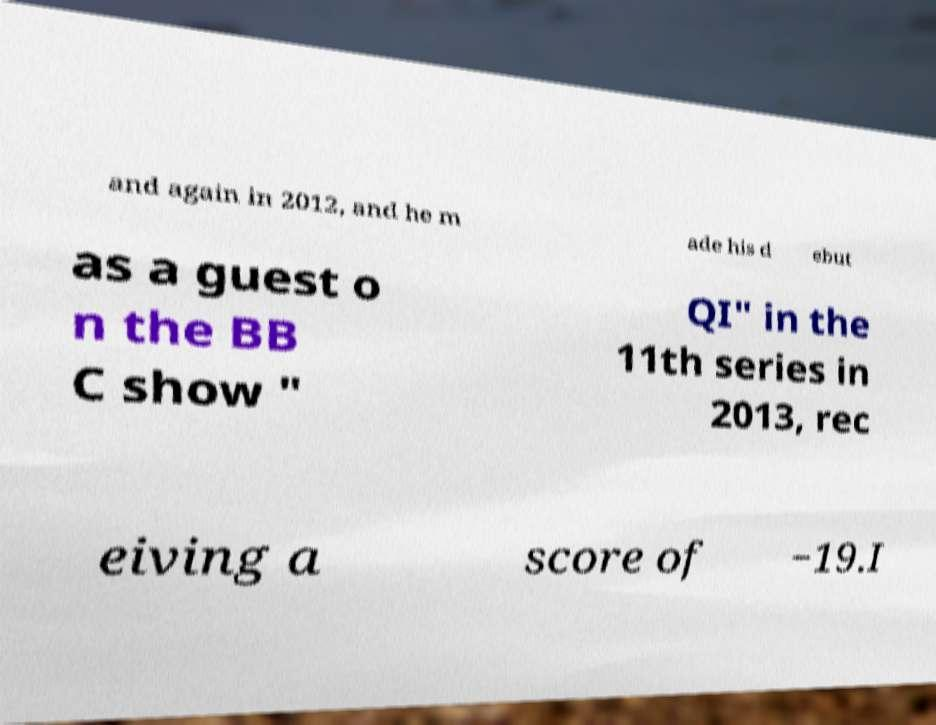Please read and relay the text visible in this image. What does it say? and again in 2012, and he m ade his d ebut as a guest o n the BB C show " QI" in the 11th series in 2013, rec eiving a score of −19.I 